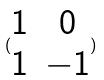<formula> <loc_0><loc_0><loc_500><loc_500>( \begin{matrix} 1 & 0 \\ 1 & - 1 \end{matrix} )</formula> 